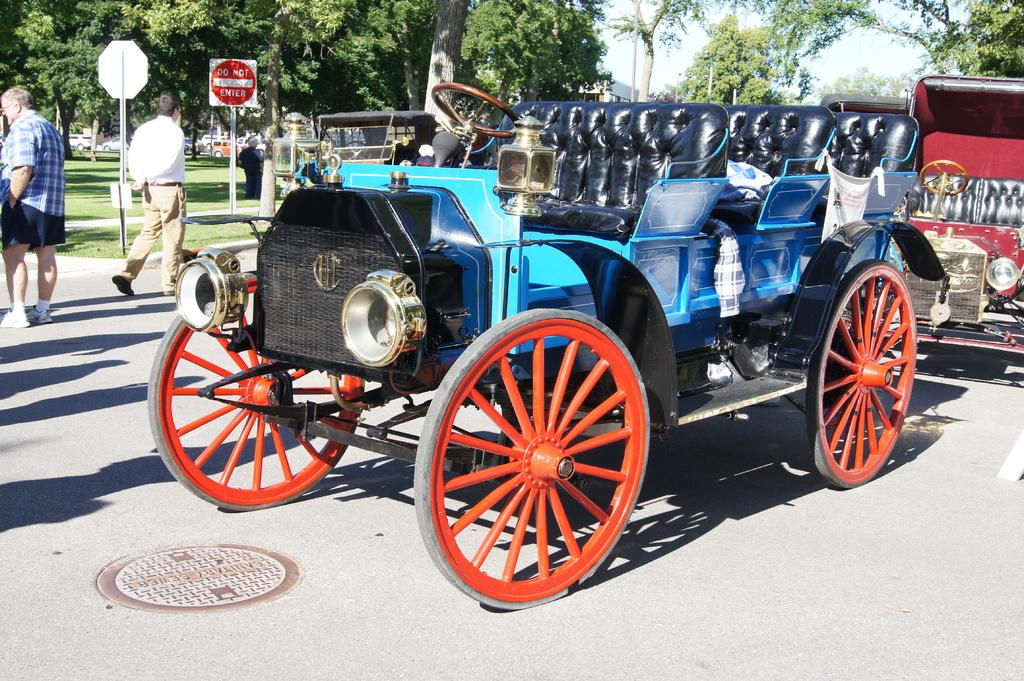What can be seen on the road in the image? There are vehicles on the road in the image. Are there any people present on the road? Yes, there are two persons on the road in the image. What structures can be seen in the image? There are poles and boards visible in the image. What type of natural elements are present in the image? There is grass and trees in the image. What is visible in the background of the image? The sky is visible in the background of the image. Can you see any ducks swimming in the waves in the image? There are no ducks or waves present in the image. How much does the ticket cost in the image? There is no ticket present in the image. 